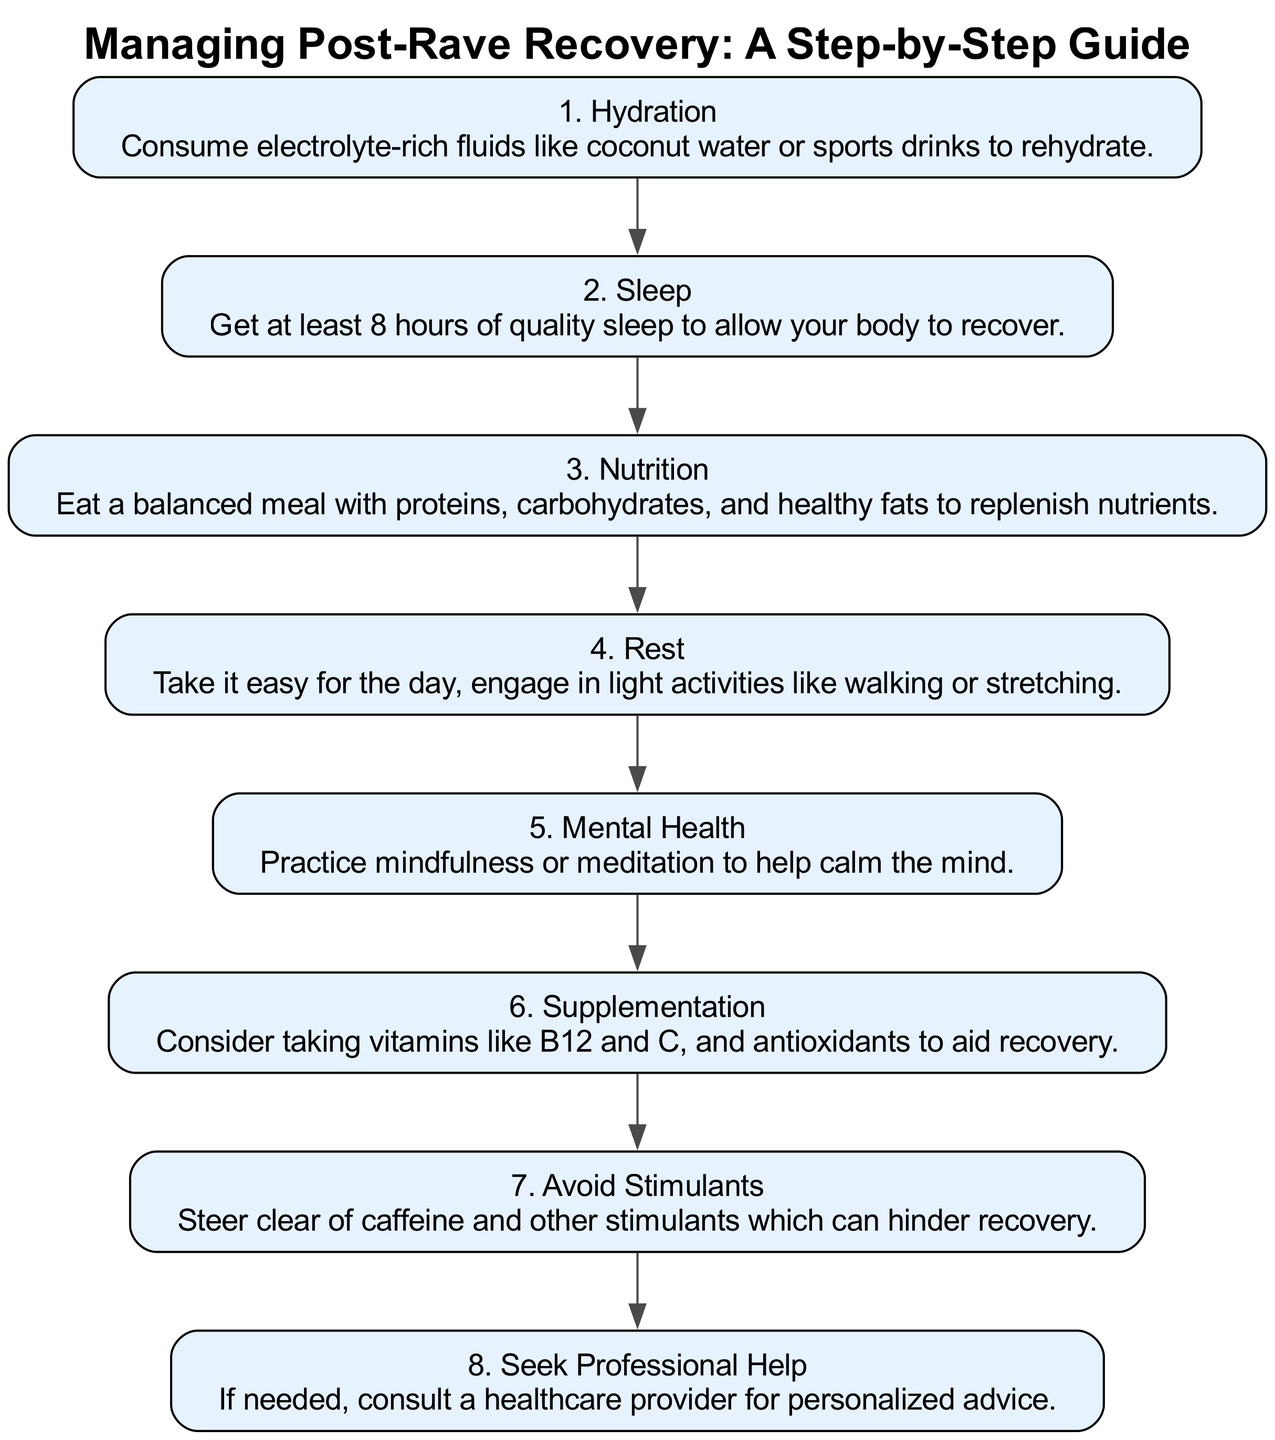What is the first step in post-rave recovery? The diagram indicates that the first step is "Hydration," which is shown as the first node in the pathway.
Answer: Hydration How many steps are there in total? By counting the individual steps presented in the pathway, there are a total of eight steps listed sequentially.
Answer: Eight What should you do after Sleep? According to the diagram, the next step after "Sleep" (Step 2) is "Nutrition," which is directly linked to Sleep in the sequence.
Answer: Nutrition Which step includes practicing mindfulness? The step that includes practicing mindfulness is "Mental Health," which is specified in the diagram as one of the recovery steps.
Answer: Mental Health What is advised regarding stimulants? The diagram advises to "Avoid Stimulants," which is listed as a specific step in the recovery process.
Answer: Avoid Stimulants What step immediately precedes Seeking Professional Help? The step immediately before "Seek Professional Help" is "Avoid Stimulants," indicating that one should first avoid substances before seeking help.
Answer: Avoid Stimulants Which step focuses on nutrient replenishment? The "Nutrition" step addresses the need to eat a balanced meal for replenishing nutrients after a rave.
Answer: Nutrition How do you ensure quality recovery after rave attendance? The diagram outlines several steps like Hydration, Sleep, and Nutrition, collectively aimed at ensuring a quality recovery process.
Answer: Multiple steps What is the last step in this recovery pathway? The final step depicted in the pathway is "Seek Professional Help," marking it as the conclusion of the recovery process.
Answer: Seek Professional Help 